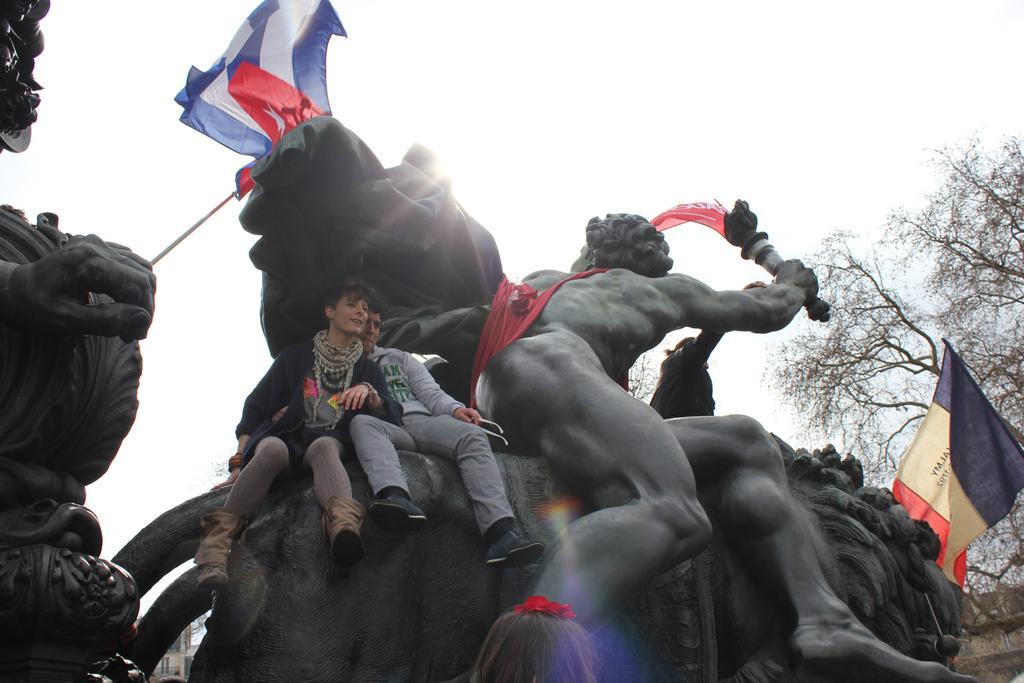In one or two sentences, can you explain what this image depicts? In this picture I can see two person are sitting on the sculpture, side there are some flags and some trees around. 